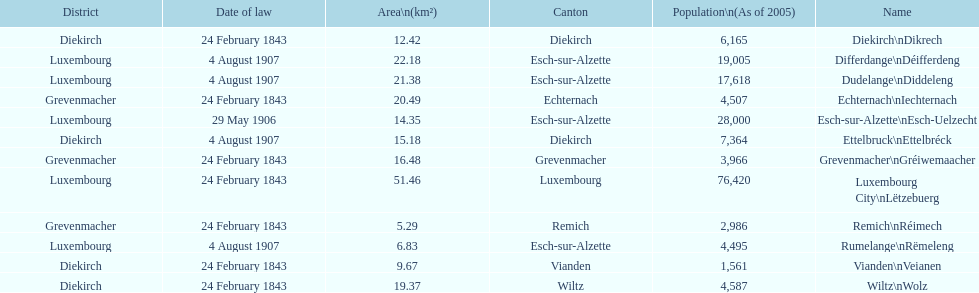How many diekirch districts also have diekirch as their canton? 2. 